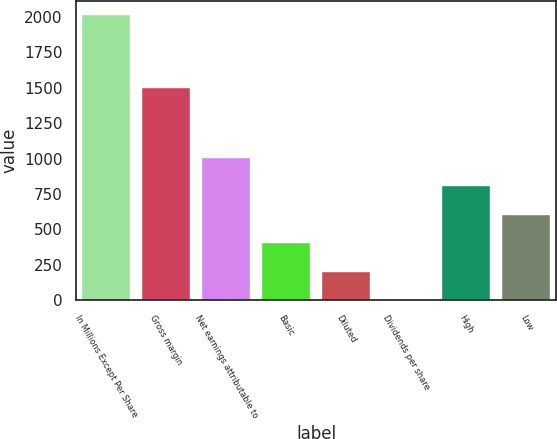<chart> <loc_0><loc_0><loc_500><loc_500><bar_chart><fcel>In Millions Except Per Share<fcel>Gross margin<fcel>Net earnings attributable to<fcel>Basic<fcel>Diluted<fcel>Dividends per share<fcel>High<fcel>Low<nl><fcel>2012<fcel>1496.1<fcel>1006.15<fcel>402.64<fcel>201.47<fcel>0.3<fcel>804.98<fcel>603.81<nl></chart> 